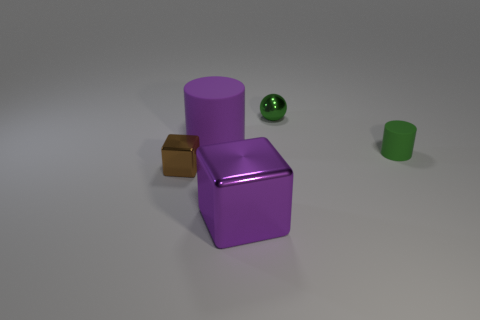Subtract all spheres. How many objects are left? 4 Add 3 blue rubber cylinders. How many objects exist? 8 Subtract all large cyan rubber cylinders. Subtract all tiny green cylinders. How many objects are left? 4 Add 1 big cylinders. How many big cylinders are left? 2 Add 1 small objects. How many small objects exist? 4 Subtract 0 yellow cylinders. How many objects are left? 5 Subtract 1 balls. How many balls are left? 0 Subtract all gray cubes. Subtract all blue cylinders. How many cubes are left? 2 Subtract all purple balls. How many cyan cylinders are left? 0 